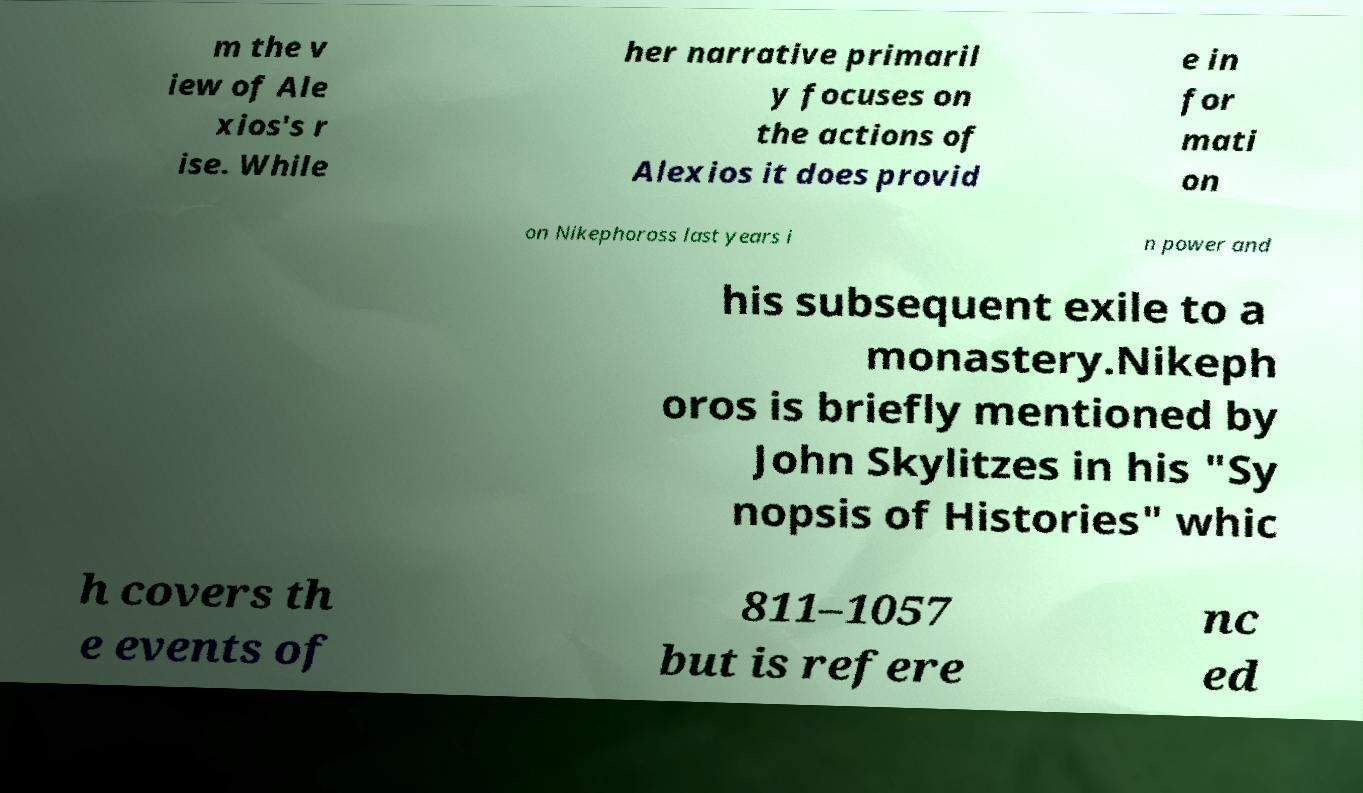I need the written content from this picture converted into text. Can you do that? m the v iew of Ale xios's r ise. While her narrative primaril y focuses on the actions of Alexios it does provid e in for mati on on Nikephoross last years i n power and his subsequent exile to a monastery.Nikeph oros is briefly mentioned by John Skylitzes in his "Sy nopsis of Histories" whic h covers th e events of 811–1057 but is refere nc ed 